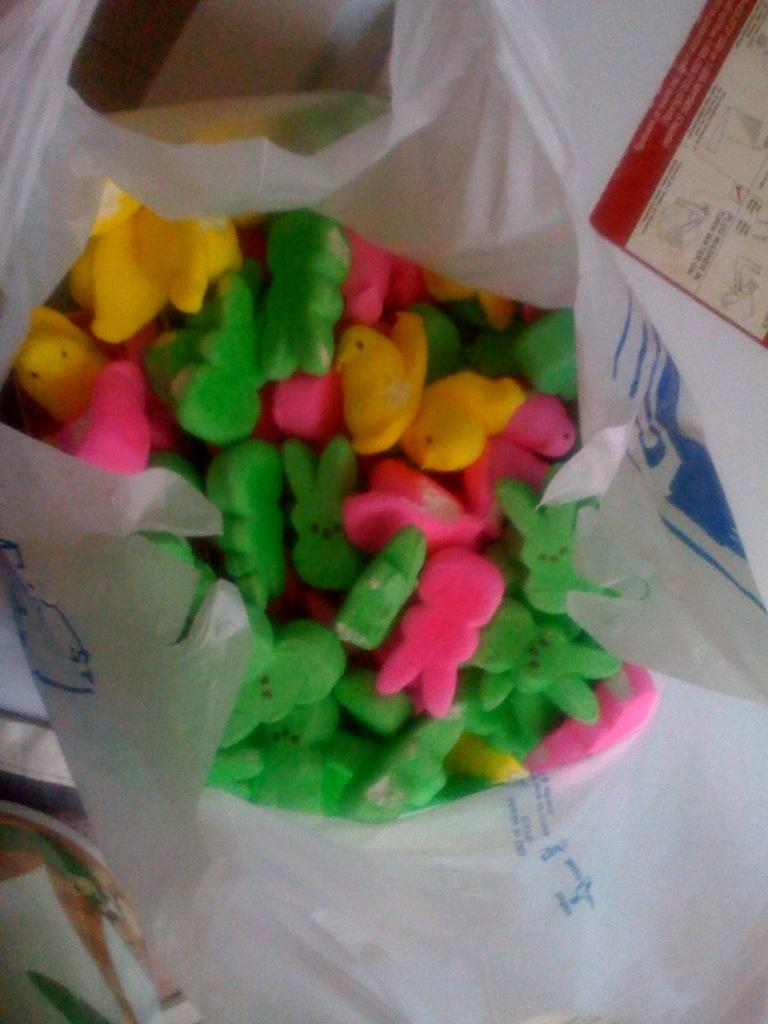What objects are present in the image? There are erasers of different colors in the image. What are the specific colors of the erasers? The colors mentioned are green, pink, and yellow. How are the erasers being stored or carried? The erasers are in a carry bag. What type of celery is being used as a sign in the image? There is no celery or sign present in the image; it only features erasers in a carry bag. 